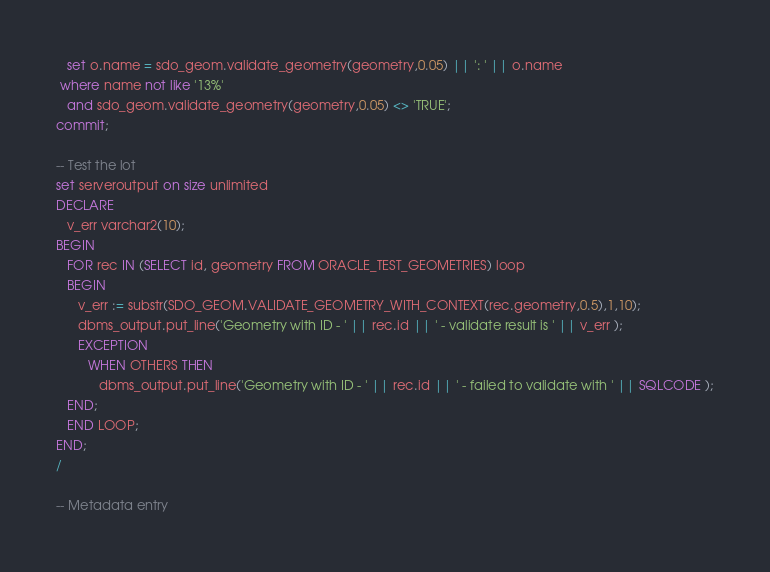Convert code to text. <code><loc_0><loc_0><loc_500><loc_500><_SQL_>   set o.name = sdo_geom.validate_geometry(geometry,0.05) || ': ' || o.name
 where name not like '13%'
   and sdo_geom.validate_geometry(geometry,0.05) <> 'TRUE';
commit;

-- Test the lot
set serveroutput on size unlimited
DECLARE
   v_err varchar2(10);
BEGIN
   FOR rec IN (SELECT id, geometry FROM ORACLE_TEST_GEOMETRIES) loop
   BEGIN
      v_err := substr(SDO_GEOM.VALIDATE_GEOMETRY_WITH_CONTEXT(rec.geometry,0.5),1,10); 
      dbms_output.put_line('Geometry with ID - ' || rec.id || ' - validate result is ' || v_err );
      EXCEPTION 
         WHEN OTHERS THEN
            dbms_output.put_line('Geometry with ID - ' || rec.id || ' - failed to validate with ' || SQLCODE );
   END;
   END LOOP;
END;
/

-- Metadata entry</code> 